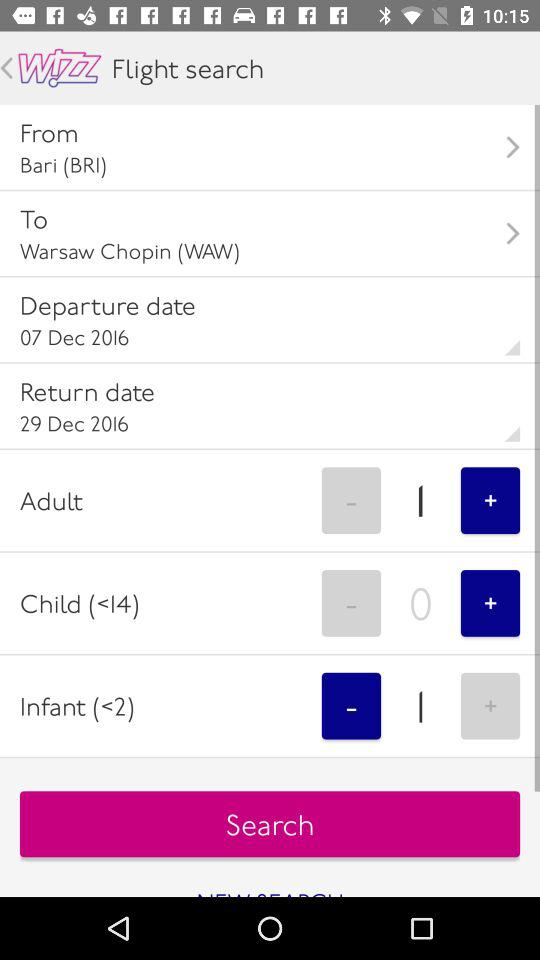What is the departure date? The departure date is 7th December, 2016. 